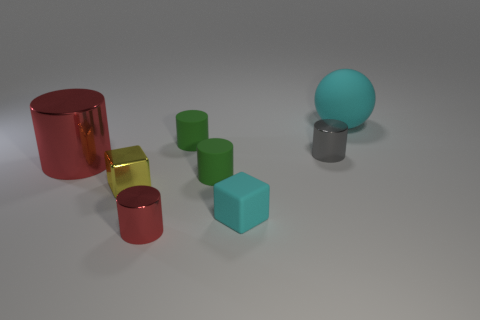What size is the sphere that is the same color as the matte cube?
Your answer should be compact. Large. There is a object in front of the cyan block; what color is it?
Your response must be concise. Red. There is a metal thing in front of the tiny cyan cube; is it the same color as the large metallic thing?
Ensure brevity in your answer.  Yes. There is another red metal object that is the same shape as the small red object; what size is it?
Offer a very short reply. Large. There is a cube that is to the right of the red metal thing that is in front of the yellow cube that is left of the small gray metallic object; what is it made of?
Your response must be concise. Rubber. Is the number of gray cylinders behind the large red cylinder greater than the number of yellow metal blocks behind the cyan sphere?
Ensure brevity in your answer.  Yes. Is the gray thing the same size as the matte cube?
Keep it short and to the point. Yes. What color is the big object that is the same shape as the small red metallic thing?
Provide a succinct answer. Red. What number of large cylinders are the same color as the sphere?
Your answer should be compact. 0. Is the number of big red cylinders behind the tiny cyan object greater than the number of big purple metal cylinders?
Provide a succinct answer. Yes. 